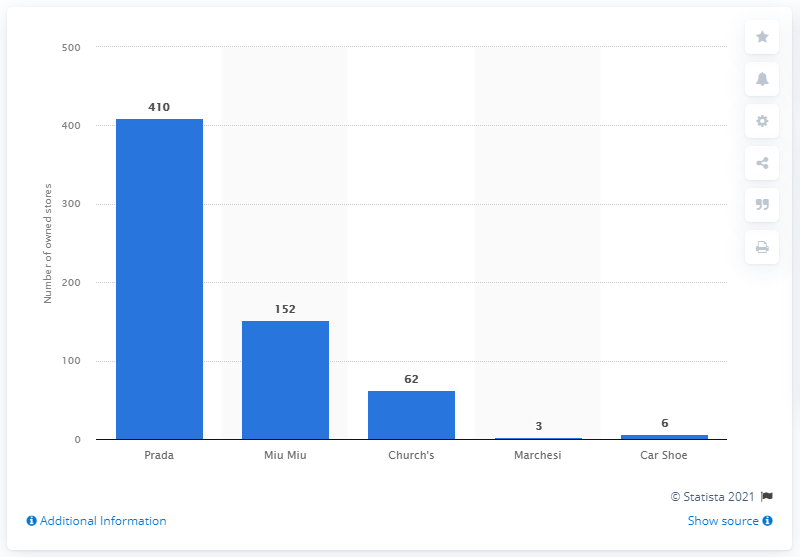Specify some key components in this picture. In 2020, there were 410 Directly Operated Stores of Prada. 